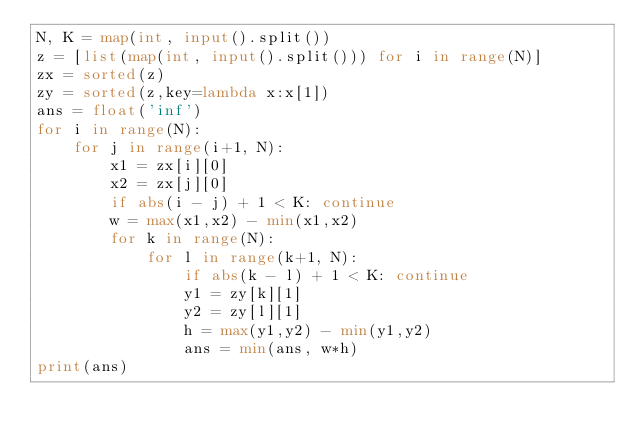Convert code to text. <code><loc_0><loc_0><loc_500><loc_500><_Python_>N, K = map(int, input().split())
z = [list(map(int, input().split())) for i in range(N)]
zx = sorted(z)
zy = sorted(z,key=lambda x:x[1])
ans = float('inf')
for i in range(N):
    for j in range(i+1, N):
        x1 = zx[i][0]
        x2 = zx[j][0]
        if abs(i - j) + 1 < K: continue
        w = max(x1,x2) - min(x1,x2)
        for k in range(N):
            for l in range(k+1, N):
                if abs(k - l) + 1 < K: continue
                y1 = zy[k][1]
                y2 = zy[l][1]
                h = max(y1,y2) - min(y1,y2)
                ans = min(ans, w*h)
print(ans)</code> 